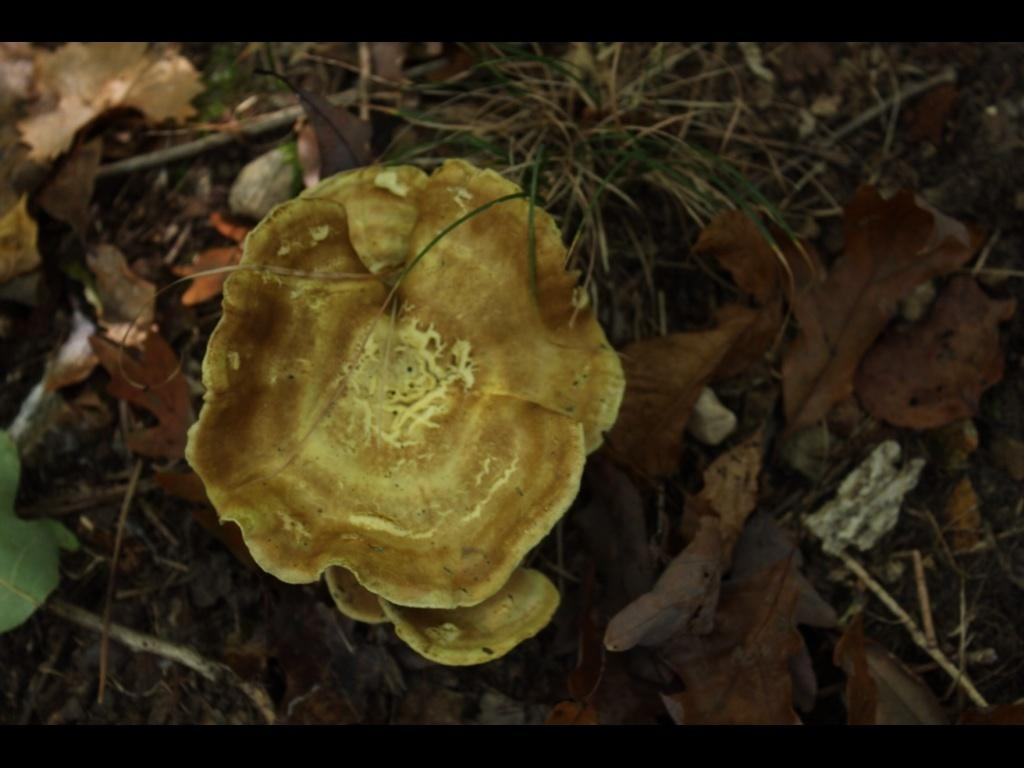What type of plant can be seen in the image? There is a flower in the image. What can be found on the ground in the image? There are dried leaves on the ground in the image. What type of vegetation is visible in the background of the image? There is grass visible in the background of the image. Is the existence of a mountain confirmed in the image? No, there is no mention of a mountain in the image. 